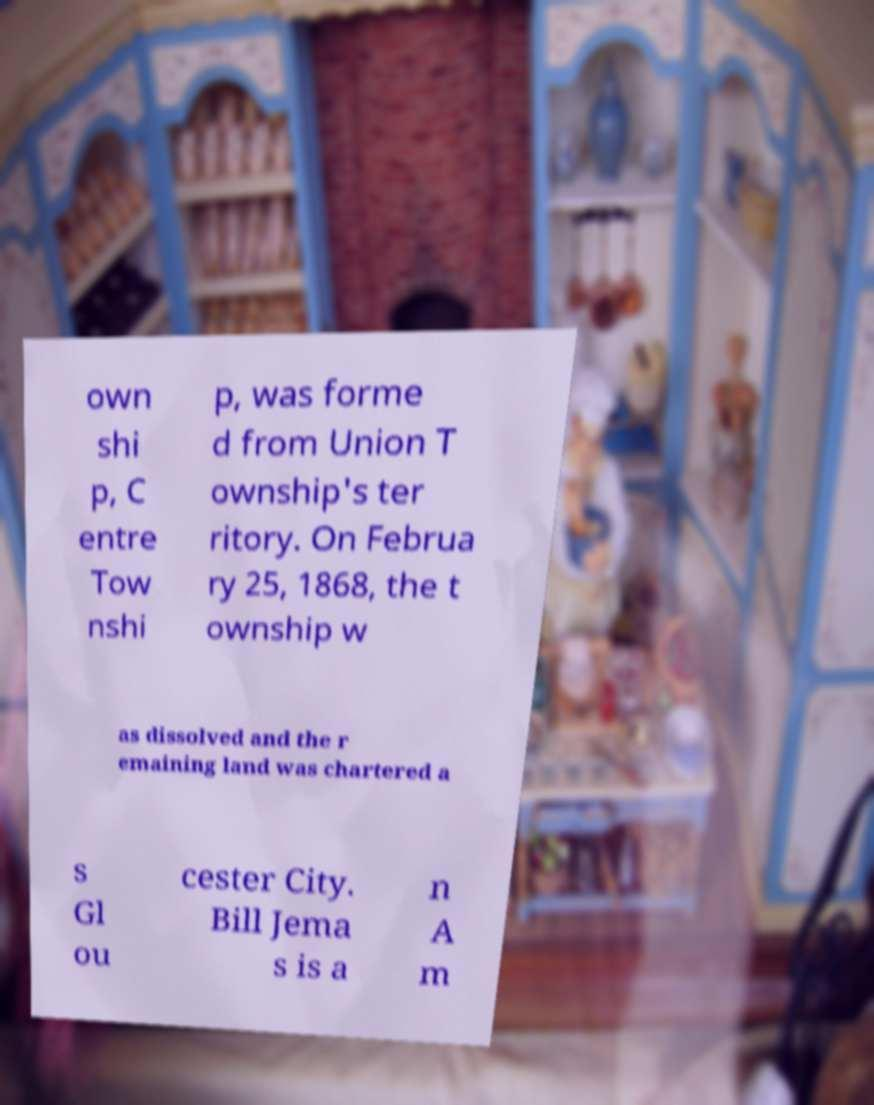Can you read and provide the text displayed in the image?This photo seems to have some interesting text. Can you extract and type it out for me? own shi p, C entre Tow nshi p, was forme d from Union T ownship's ter ritory. On Februa ry 25, 1868, the t ownship w as dissolved and the r emaining land was chartered a s Gl ou cester City. Bill Jema s is a n A m 